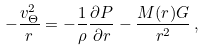<formula> <loc_0><loc_0><loc_500><loc_500>- \frac { v _ { \Theta } ^ { 2 } } { r } = - \frac { 1 } { \rho } \frac { \partial P } { \partial r } - \frac { M ( r ) G } { r ^ { 2 } } \, ,</formula> 